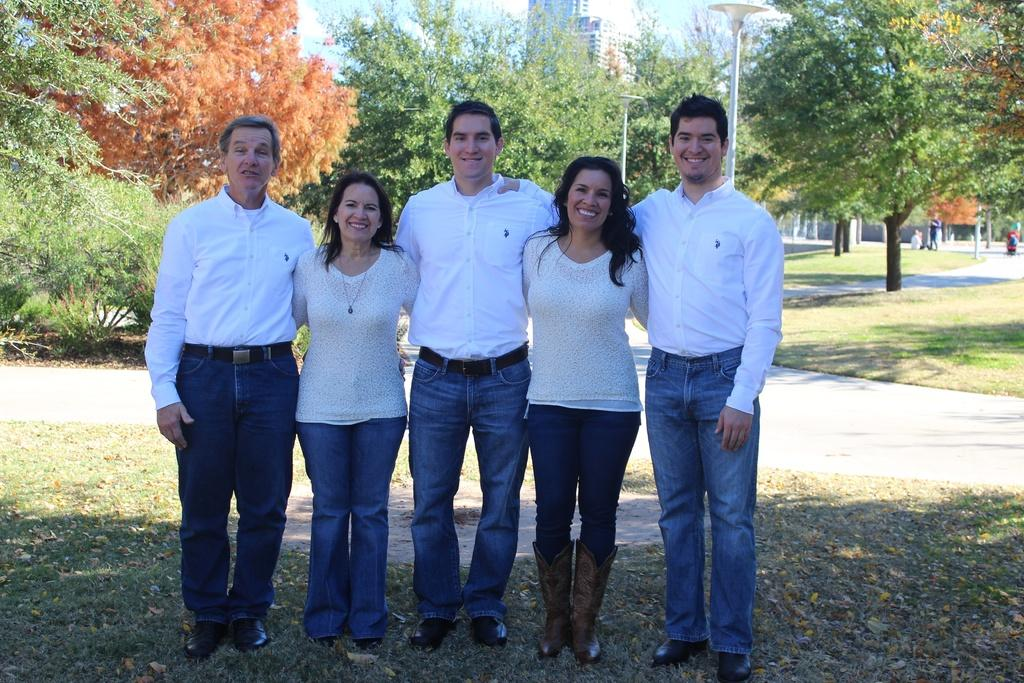What can be seen in the image? There are people standing in the image. What are the people wearing? The people are wearing white tops and jeans. What type of vegetation is visible in the image? There are trees visible in the image. What structures can be seen in the image? There are poles and a building in the image. What is the color of the sky in the image? The sky is blue and white in color. What type of sound can be heard coming from the cannon in the image? There is no cannon present in the image, so no sound can be heard from it. 